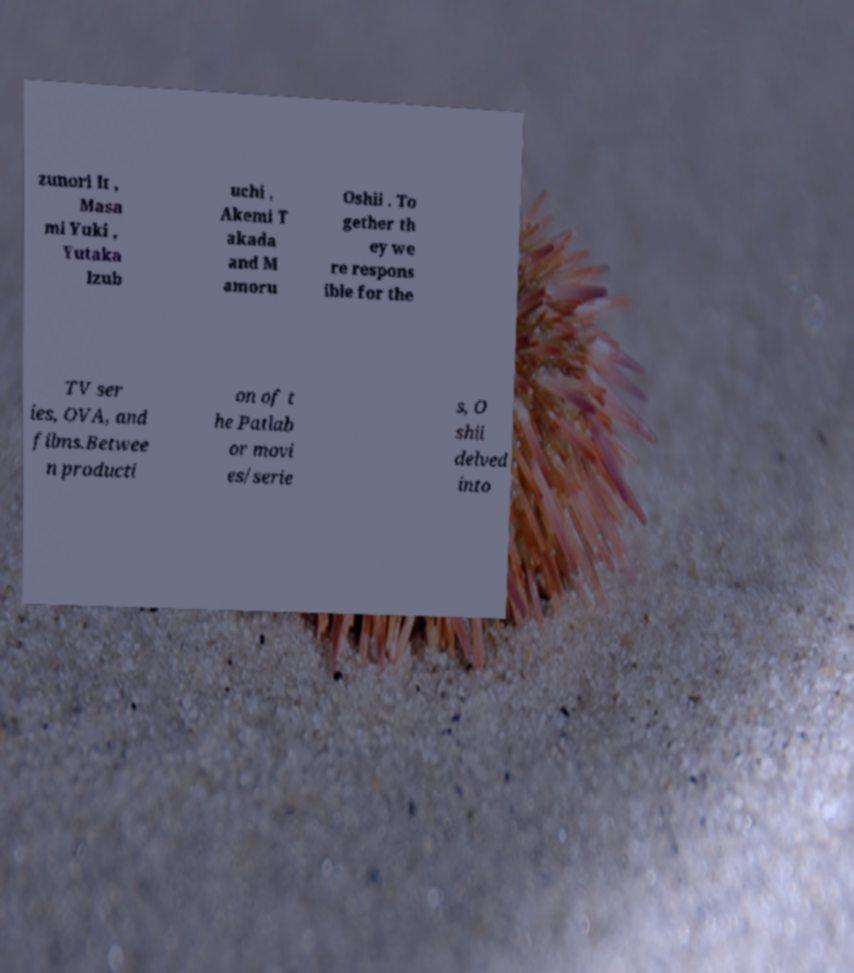Please identify and transcribe the text found in this image. zunori It , Masa mi Yuki , Yutaka Izub uchi , Akemi T akada and M amoru Oshii . To gether th ey we re respons ible for the TV ser ies, OVA, and films.Betwee n producti on of t he Patlab or movi es/serie s, O shii delved into 